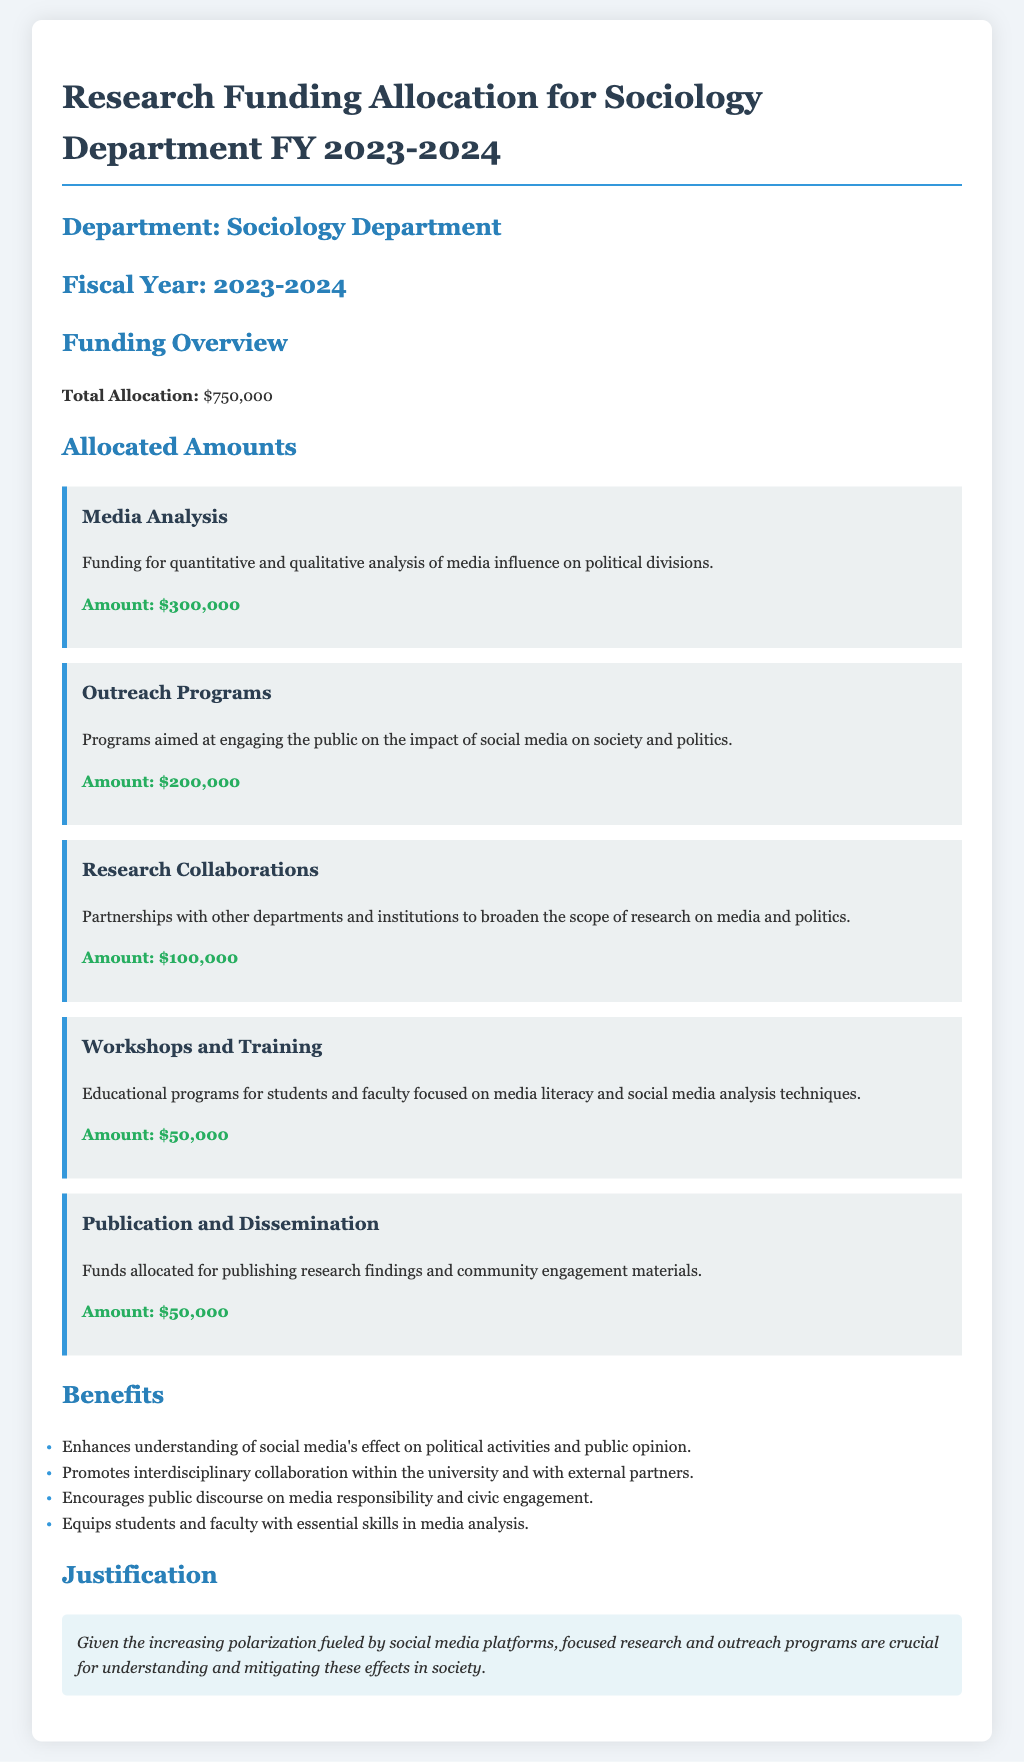What is the total allocation for the Sociology Department? The total allocation is stated clearly under the funding overview section.
Answer: $750,000 How much funding is allocated for Media Analysis? The amount for Media Analysis can be found in the allocated amounts section.
Answer: $300,000 What is the purpose of the Outreach Programs funding? The purpose of the Outreach Programs is described in the context provided under its title.
Answer: Engaging the public on the impact of social media on society and politics What is the allocated amount for Workshops and Training? The amount designated for Workshops and Training is also listed in the allocated amounts section.
Answer: $50,000 What is the justification for the funding allocations? The justification can be found at the end of the document, summarizing the need for the funding.
Answer: Understanding and mitigating effects of polarization fueled by social media What is the focus of the Workshops and Training programs? The focus is highlighted in the description under the Workshops and Training section.
Answer: Media literacy and social media analysis techniques How much is allocated for Research Collaborations? The document specifies the amount allocated for Research Collaborations in the funding items.
Answer: $100,000 What is one benefit of the funding outlined in the document? Benefits are listed in bullet points, highlighting the advantages of the funding.
Answer: Enhances understanding of social media's effect on political activities and public opinion 